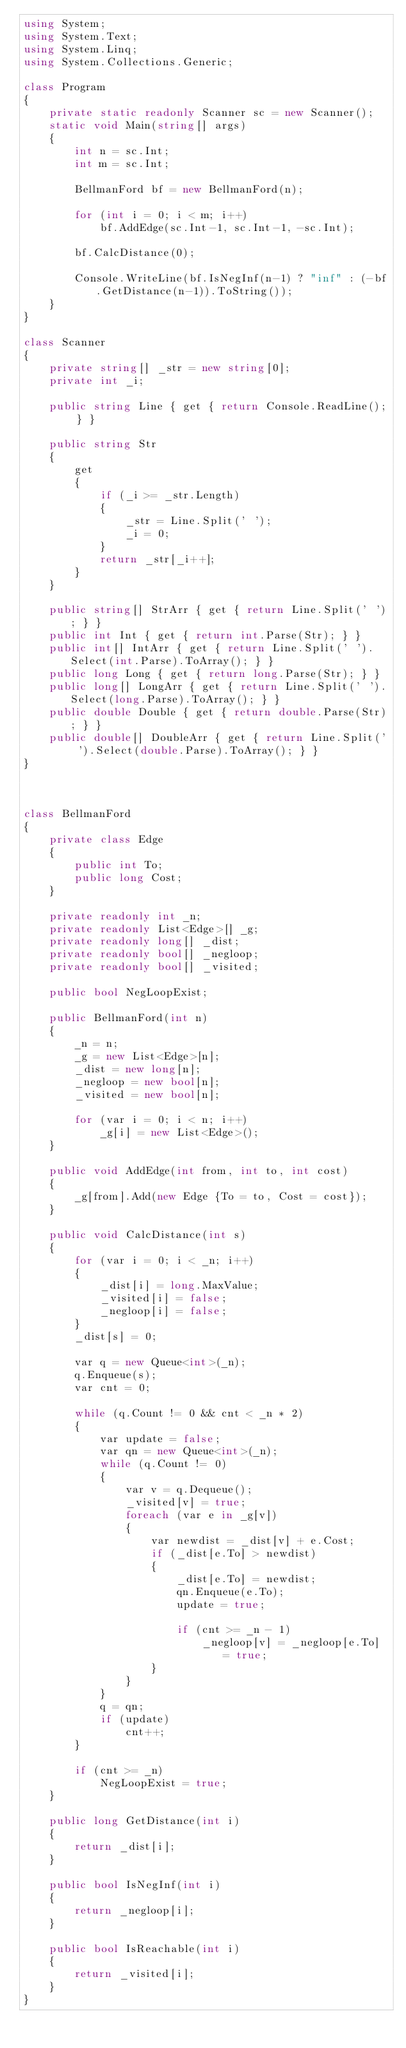<code> <loc_0><loc_0><loc_500><loc_500><_C#_>using System;
using System.Text;
using System.Linq;
using System.Collections.Generic;

class Program
{
    private static readonly Scanner sc = new Scanner();
    static void Main(string[] args)
    {
        int n = sc.Int;
        int m = sc.Int;

        BellmanFord bf = new BellmanFord(n);

        for (int i = 0; i < m; i++)
            bf.AddEdge(sc.Int-1, sc.Int-1, -sc.Int);

        bf.CalcDistance(0);

        Console.WriteLine(bf.IsNegInf(n-1) ? "inf" : (-bf.GetDistance(n-1)).ToString());
    }
}

class Scanner
{
    private string[] _str = new string[0];
    private int _i;

    public string Line { get { return Console.ReadLine(); } }

    public string Str
    {
        get
        {
            if (_i >= _str.Length)
            {
                _str = Line.Split(' ');
                _i = 0;
            }
            return _str[_i++];
        }
    }

    public string[] StrArr { get { return Line.Split(' '); } }
    public int Int { get { return int.Parse(Str); } }
    public int[] IntArr { get { return Line.Split(' ').Select(int.Parse).ToArray(); } }
    public long Long { get { return long.Parse(Str); } }
    public long[] LongArr { get { return Line.Split(' ').Select(long.Parse).ToArray(); } }
    public double Double { get { return double.Parse(Str); } }
    public double[] DoubleArr { get { return Line.Split(' ').Select(double.Parse).ToArray(); } }
}



class BellmanFord
{
    private class Edge
    {
        public int To;
        public long Cost;
    }

    private readonly int _n;
    private readonly List<Edge>[] _g;
    private readonly long[] _dist;
    private readonly bool[] _negloop;
    private readonly bool[] _visited;

    public bool NegLoopExist;

    public BellmanFord(int n)
    {
        _n = n;
        _g = new List<Edge>[n];
        _dist = new long[n];
        _negloop = new bool[n];
        _visited = new bool[n];

        for (var i = 0; i < n; i++)
            _g[i] = new List<Edge>();
    }

    public void AddEdge(int from, int to, int cost)
    {
        _g[from].Add(new Edge {To = to, Cost = cost});
    }

    public void CalcDistance(int s)
    {
        for (var i = 0; i < _n; i++)
        {
            _dist[i] = long.MaxValue;
            _visited[i] = false;
            _negloop[i] = false;
        }
        _dist[s] = 0;

        var q = new Queue<int>(_n);
        q.Enqueue(s);
        var cnt = 0;

        while (q.Count != 0 && cnt < _n * 2)
        {
            var update = false;
            var qn = new Queue<int>(_n);
            while (q.Count != 0)
            {
                var v = q.Dequeue();
                _visited[v] = true;
                foreach (var e in _g[v])
                {
                    var newdist = _dist[v] + e.Cost;
                    if (_dist[e.To] > newdist)
                    {
                        _dist[e.To] = newdist;
                        qn.Enqueue(e.To);
                        update = true;

                        if (cnt >= _n - 1)
                            _negloop[v] = _negloop[e.To] = true;
                    }
                }
            }
            q = qn;
            if (update)
                cnt++;
        }

        if (cnt >= _n)
            NegLoopExist = true;
    }

    public long GetDistance(int i)
    {
        return _dist[i];
    }

    public bool IsNegInf(int i)
    {
        return _negloop[i];
    }

    public bool IsReachable(int i)
    {
        return _visited[i];
    }
}</code> 